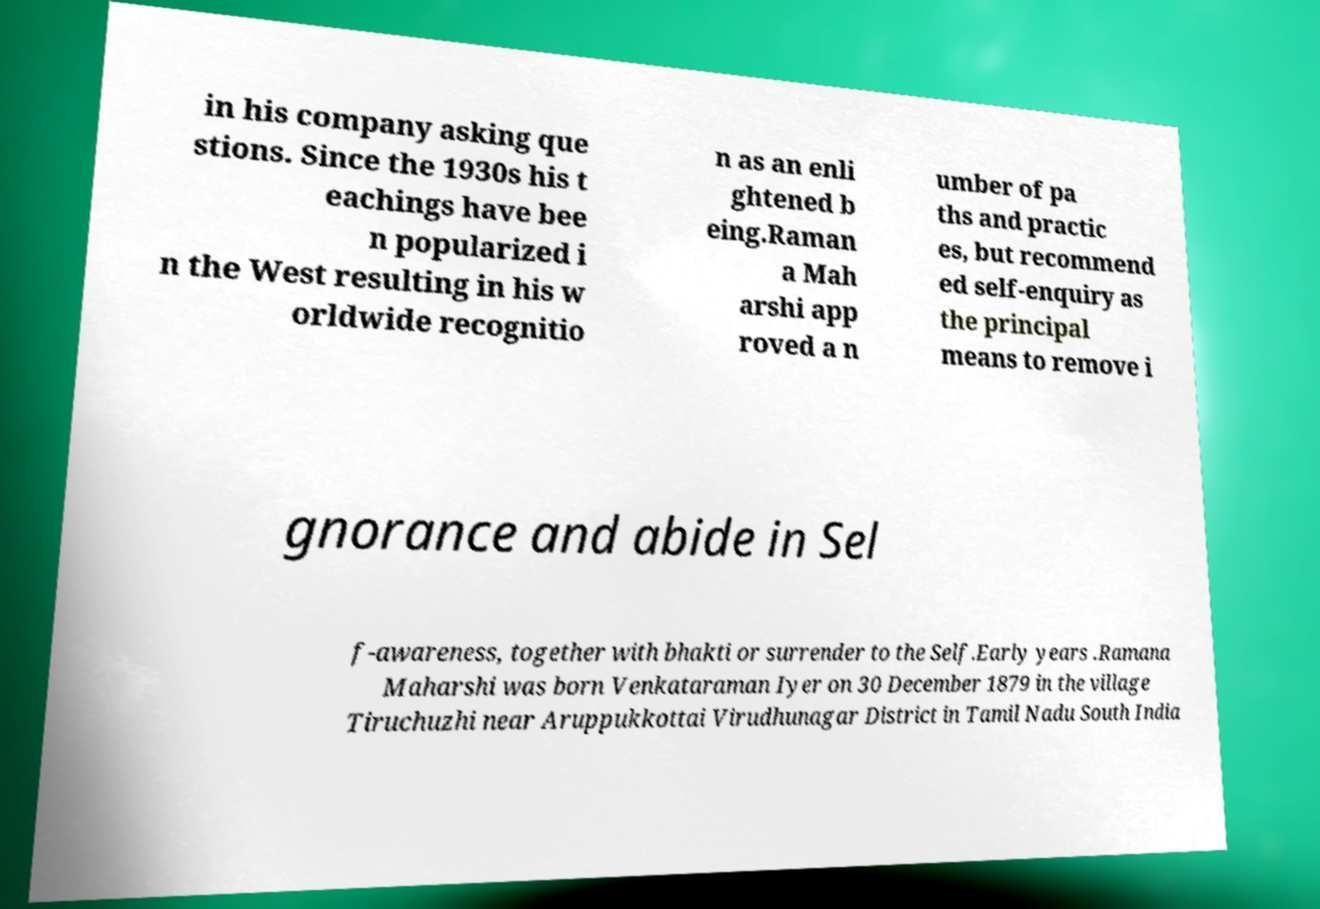Can you read and provide the text displayed in the image?This photo seems to have some interesting text. Can you extract and type it out for me? in his company asking que stions. Since the 1930s his t eachings have bee n popularized i n the West resulting in his w orldwide recognitio n as an enli ghtened b eing.Raman a Mah arshi app roved a n umber of pa ths and practic es, but recommend ed self-enquiry as the principal means to remove i gnorance and abide in Sel f-awareness, together with bhakti or surrender to the Self.Early years .Ramana Maharshi was born Venkataraman Iyer on 30 December 1879 in the village Tiruchuzhi near Aruppukkottai Virudhunagar District in Tamil Nadu South India 